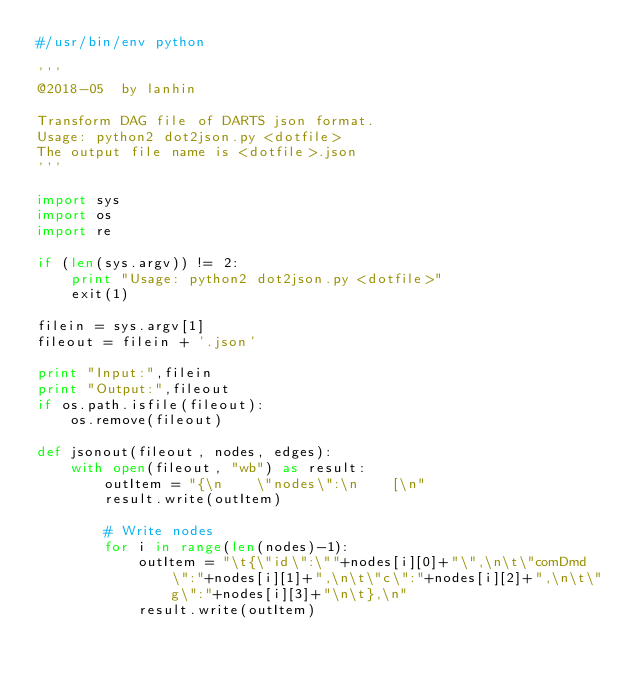Convert code to text. <code><loc_0><loc_0><loc_500><loc_500><_Python_>#/usr/bin/env python

'''
@2018-05  by lanhin

Transform DAG file of DARTS json format.
Usage: python2 dot2json.py <dotfile>
The output file name is <dotfile>.json
'''

import sys
import os
import re

if (len(sys.argv)) != 2:
    print "Usage: python2 dot2json.py <dotfile>"
    exit(1)

filein = sys.argv[1]
fileout = filein + '.json'

print "Input:",filein
print "Output:",fileout
if os.path.isfile(fileout):
    os.remove(fileout)

def jsonout(fileout, nodes, edges):
    with open(fileout, "wb") as result:
        outItem = "{\n    \"nodes\":\n    [\n"
        result.write(outItem)

        # Write nodes
        for i in range(len(nodes)-1):
            outItem = "\t{\"id\":\""+nodes[i][0]+"\",\n\t\"comDmd\":"+nodes[i][1]+",\n\t\"c\":"+nodes[i][2]+",\n\t\"g\":"+nodes[i][3]+"\n\t},\n"
            result.write(outItem)
</code> 